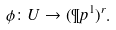<formula> <loc_0><loc_0><loc_500><loc_500>\phi \colon U \to ( \P p ^ { 1 } ) ^ { r } .</formula> 